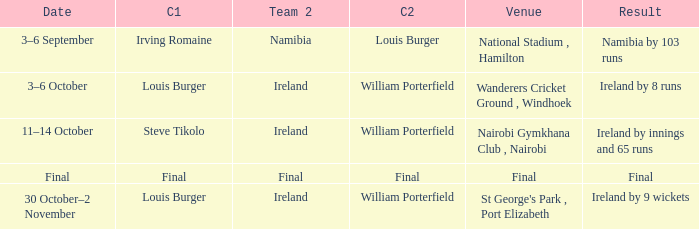Which Captain 2 has a Result of ireland by 8 runs? William Porterfield. 